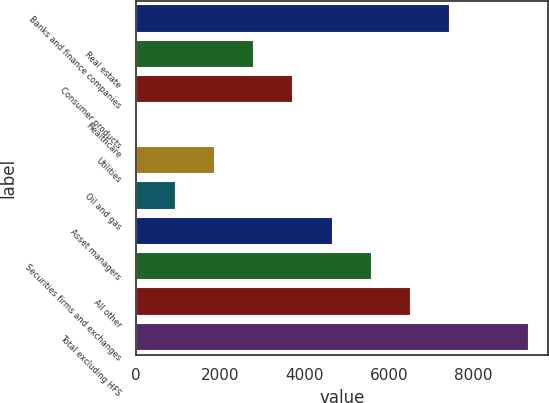Convert chart to OTSL. <chart><loc_0><loc_0><loc_500><loc_500><bar_chart><fcel>Banks and finance companies<fcel>Real estate<fcel>Consumer products<fcel>Healthcare<fcel>Utilities<fcel>Oil and gas<fcel>Asset managers<fcel>Securities firms and exchanges<fcel>All other<fcel>Total excluding HFS<nl><fcel>7443.4<fcel>2799.4<fcel>3728.2<fcel>13<fcel>1870.6<fcel>941.8<fcel>4657<fcel>5585.8<fcel>6514.6<fcel>9301<nl></chart> 